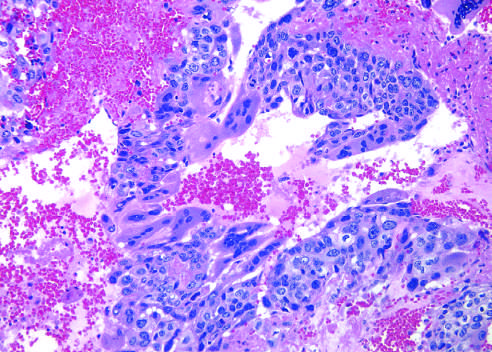re both cytotrophoblastic cells with single central nuclei and syncytiotrophoblastic cells with multiple dark nuclei embedded in eosinophilic cytoplasm present?
Answer the question using a single word or phrase. Yes 